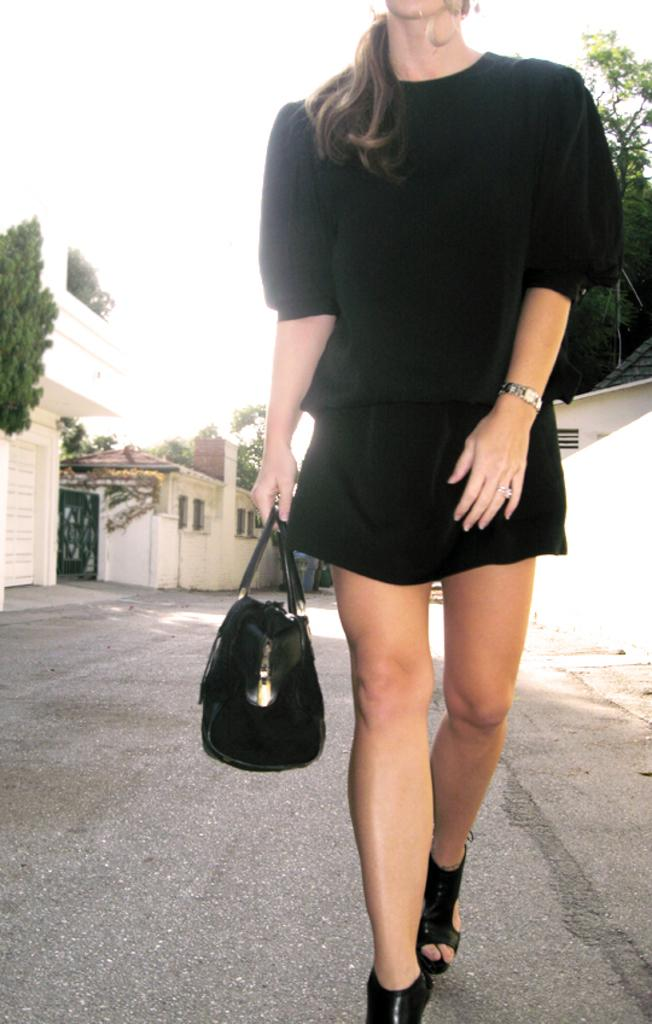Who is present in the image? There is a woman in the image. What is the woman wearing? The woman is wearing a black dress. What is the woman holding in the image? The woman is holding a black handbag. What is the woman doing in the image? The woman is walking. What can be seen in the background of the image? There is a tree, buildings, and a black gate in the image. What type of tray is the woman carrying in the image? There is no tray present in the image; the woman is holding a black handbag. How many carts can be seen in the image? There are no carts present in the image. 